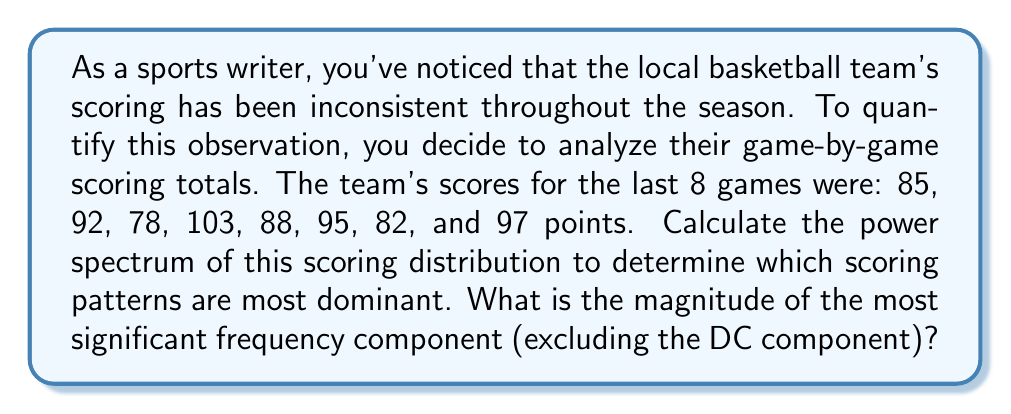Teach me how to tackle this problem. To calculate the power spectrum of the team's scoring distribution, we'll follow these steps:

1) First, we need to compute the Discrete Fourier Transform (DFT) of the scoring data. For a sequence $x[n]$ of length $N$, the DFT is given by:

   $$X[k] = \sum_{n=0}^{N-1} x[n] e^{-j2\pi kn/N}$$

   where $k = 0, 1, ..., N-1$

2) In this case, $N = 8$ and our sequence is:
   $x = [85, 92, 78, 103, 88, 95, 82, 97]$

3) We'll compute $X[k]$ for $k = 0$ to $7$:

   $X[0] = 720$
   $X[1] = -7 - 21j$
   $X[2] = 14 + 2j$
   $X[3] = 1 + 5j$
   $X[4] = -8$
   $X[5] = 1 - 5j$
   $X[6] = 14 - 2j$
   $X[7] = -7 + 21j$

4) The power spectrum is the squared magnitude of the DFT:

   $$P[k] = |X[k]|^2$$

5) Computing $P[k]$:

   $P[0] = 518400$ (DC component)
   $P[1] = 490$
   $P[2] = 200$
   $P[3] = 26$
   $P[4] = 64$
   $P[5] = 26$
   $P[6] = 200$
   $P[7] = 490$

6) The DC component ($P[0]$) represents the average power and is typically much larger than the other components. Excluding this, the most significant frequency components are $P[1]$ and $P[7]$, both with a magnitude of 490.

Therefore, the magnitude of the most significant frequency component (excluding the DC component) is $\sqrt{490} \approx 22.14$.
Answer: $22.14$ (rounded to two decimal places) 